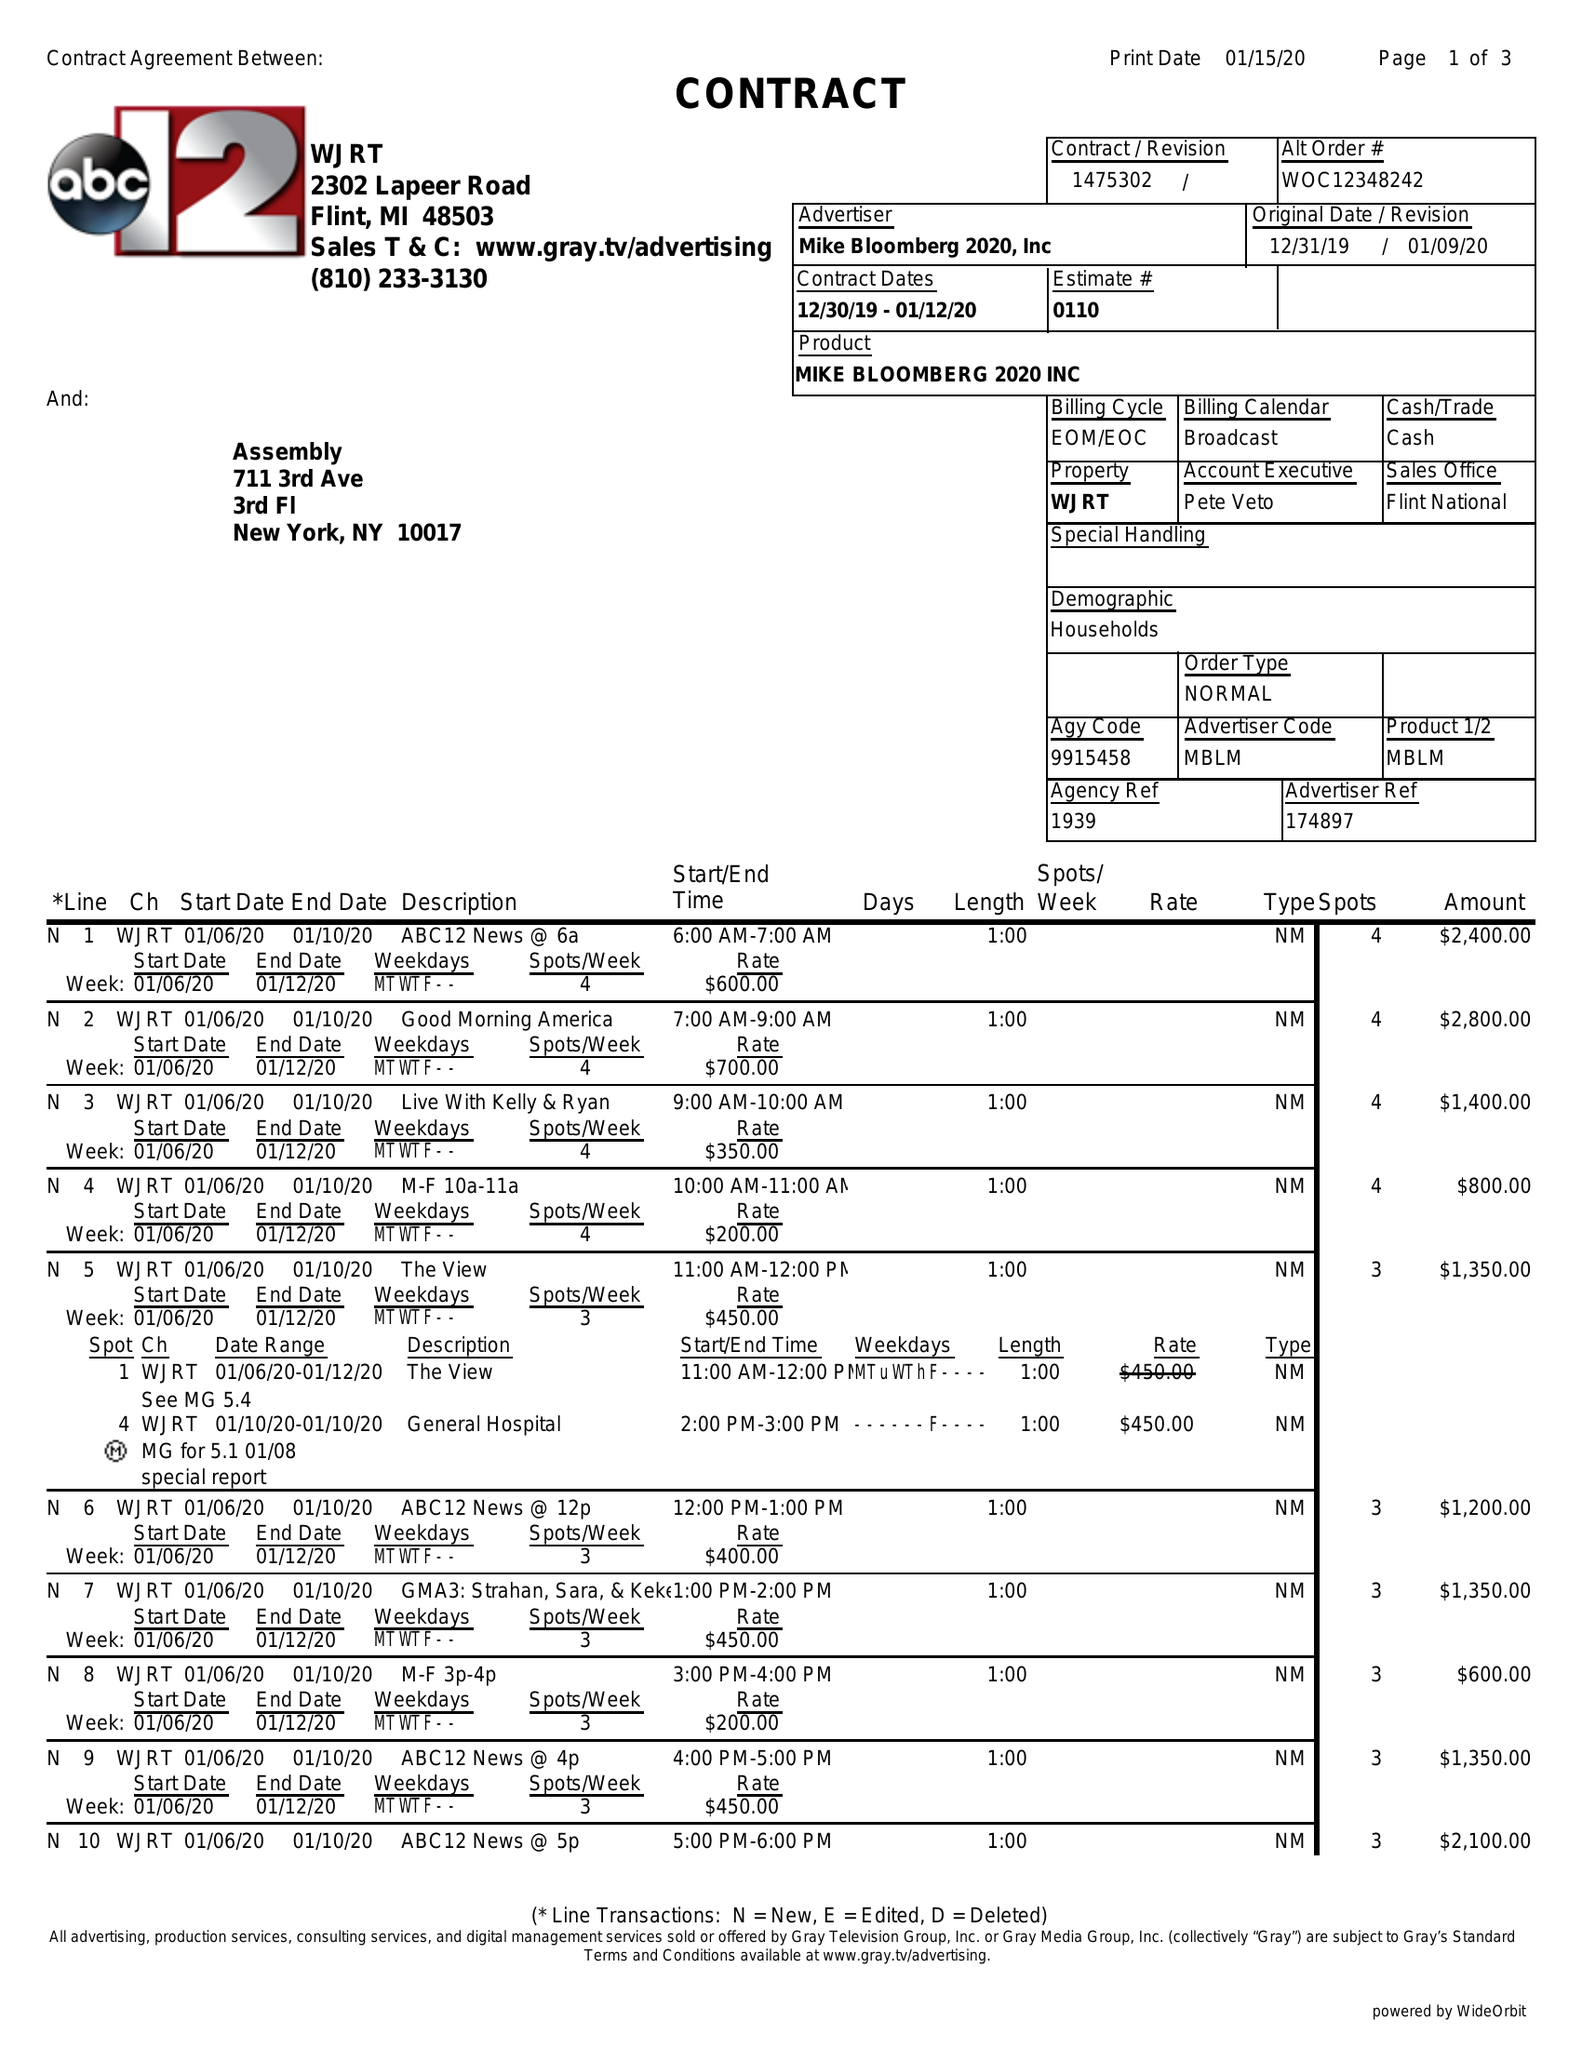What is the value for the gross_amount?
Answer the question using a single word or phrase. 42350.00 